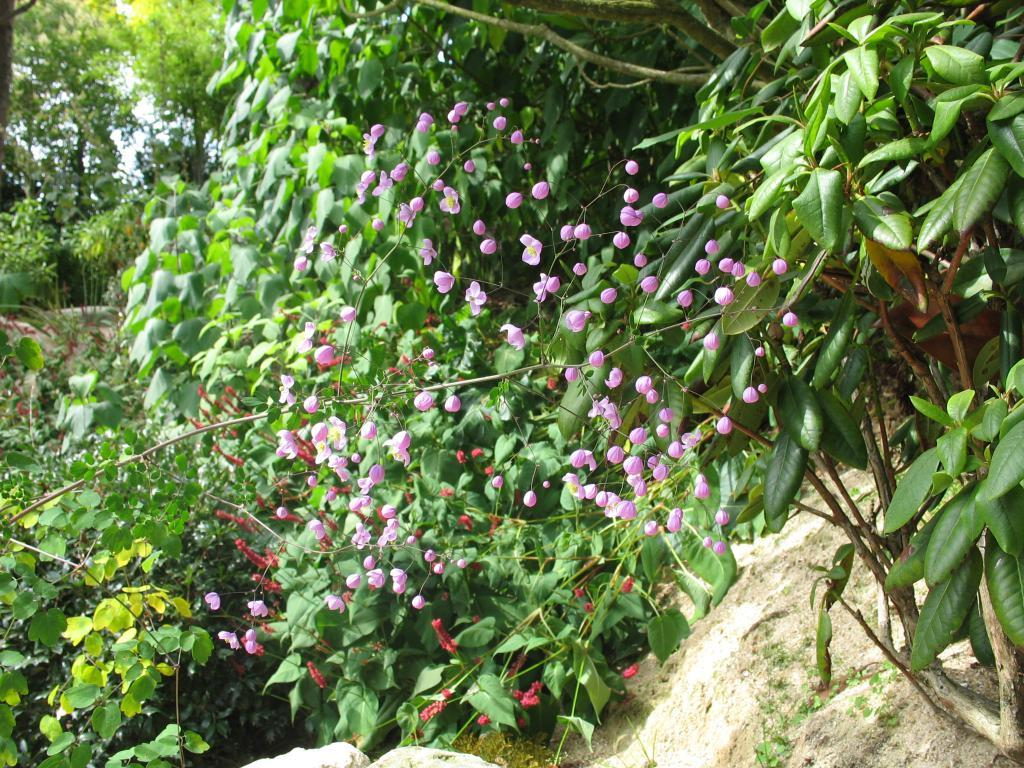What type of vegetation is present in the image? There are many trees and plants in the image. Are there any specific features of the plants in the image? Yes, the plants have flowers on them. How many clocks can be seen hanging from the trees in the image? There are no clocks visible in the image; it features trees and plants with flowers. Are there any shoes visible among the plants in the image? There are no shoes present in the image; it features trees and plants with flowers. 